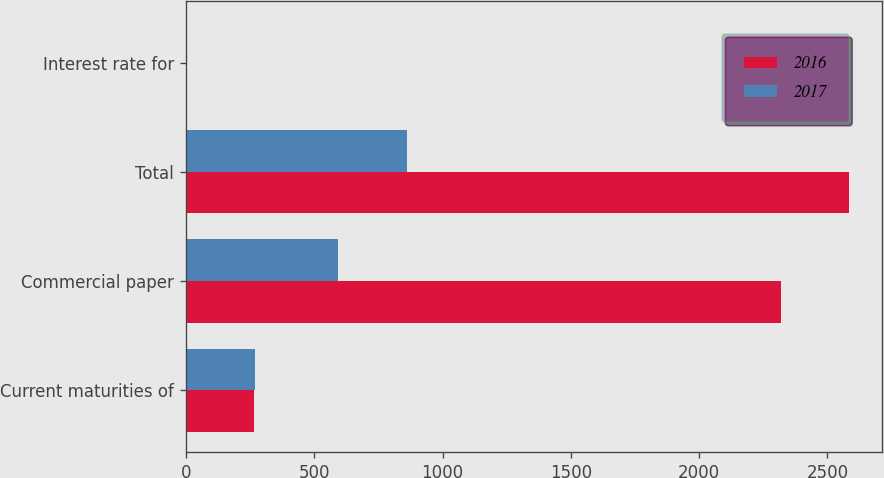Convert chart. <chart><loc_0><loc_0><loc_500><loc_500><stacked_bar_chart><ecel><fcel>Current maturities of<fcel>Commercial paper<fcel>Total<fcel>Interest rate for<nl><fcel>2016<fcel>267<fcel>2317<fcel>2584<fcel>0.5<nl><fcel>2017<fcel>270<fcel>592<fcel>862<fcel>1.1<nl></chart> 